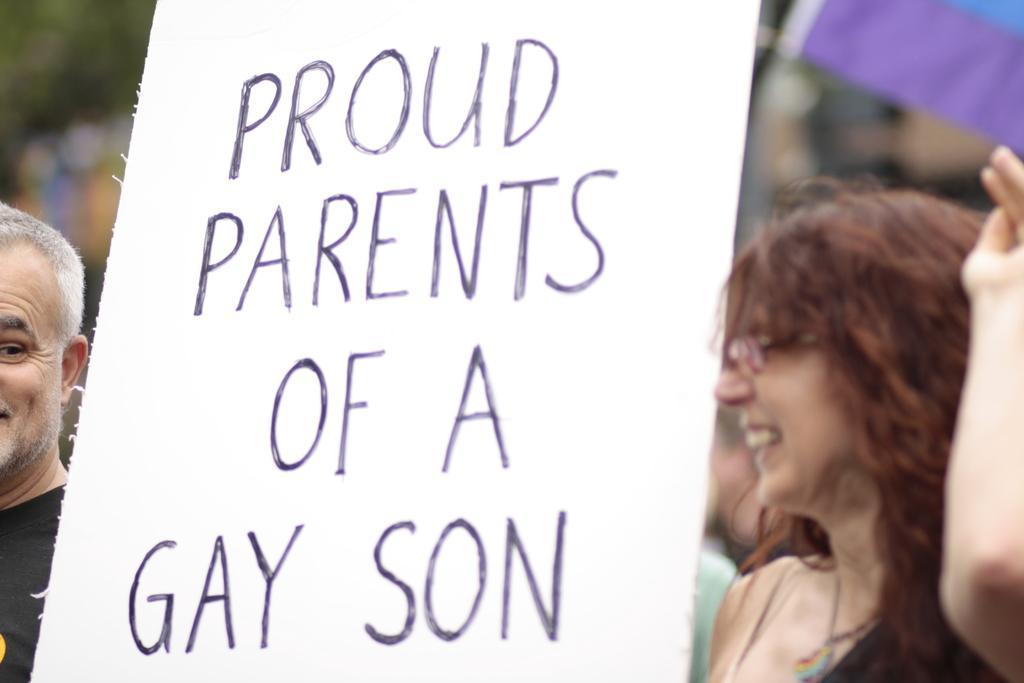Describe this image in one or two sentences. In this picture I can see a man and a woman standing and I can see a board with some text and I can see a flag , looks like few people standing on the back. 